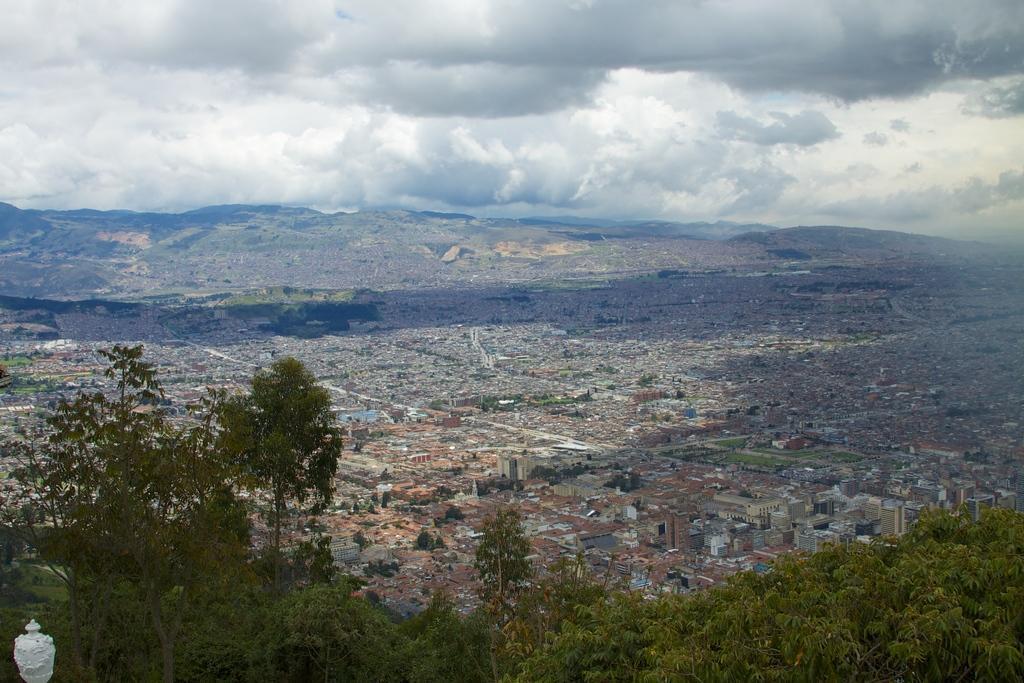Can you describe this image briefly? In this image we can see buildings, trees. In the background of the image there are mountains, clouds. 